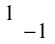<formula> <loc_0><loc_0><loc_500><loc_500>\begin{smallmatrix} 1 & \\ & - 1 \end{smallmatrix}</formula> 